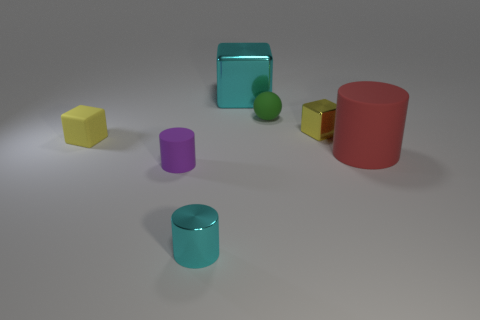Is the material of the object on the left side of the tiny purple cylinder the same as the yellow block that is on the right side of the big cyan metallic thing?
Offer a terse response. No. There is a large red matte object that is behind the small cylinder that is in front of the rubber object that is in front of the big red matte cylinder; what is its shape?
Keep it short and to the point. Cylinder. How many big purple things have the same material as the large cyan block?
Provide a succinct answer. 0. How many small rubber blocks are on the left side of the rubber cylinder in front of the large red cylinder?
Your answer should be very brief. 1. There is a large thing that is in front of the green rubber ball; does it have the same color as the shiny thing behind the tiny matte sphere?
Give a very brief answer. No. There is a thing that is both in front of the matte cube and on the left side of the small cyan object; what shape is it?
Your answer should be compact. Cylinder. Are there any small purple matte objects of the same shape as the yellow rubber object?
Offer a terse response. No. The yellow metal object that is the same size as the green matte object is what shape?
Make the answer very short. Cube. What material is the tiny cyan cylinder?
Provide a succinct answer. Metal. There is a green matte object to the left of the small metallic thing behind the matte cylinder right of the tiny purple matte thing; how big is it?
Your response must be concise. Small. 